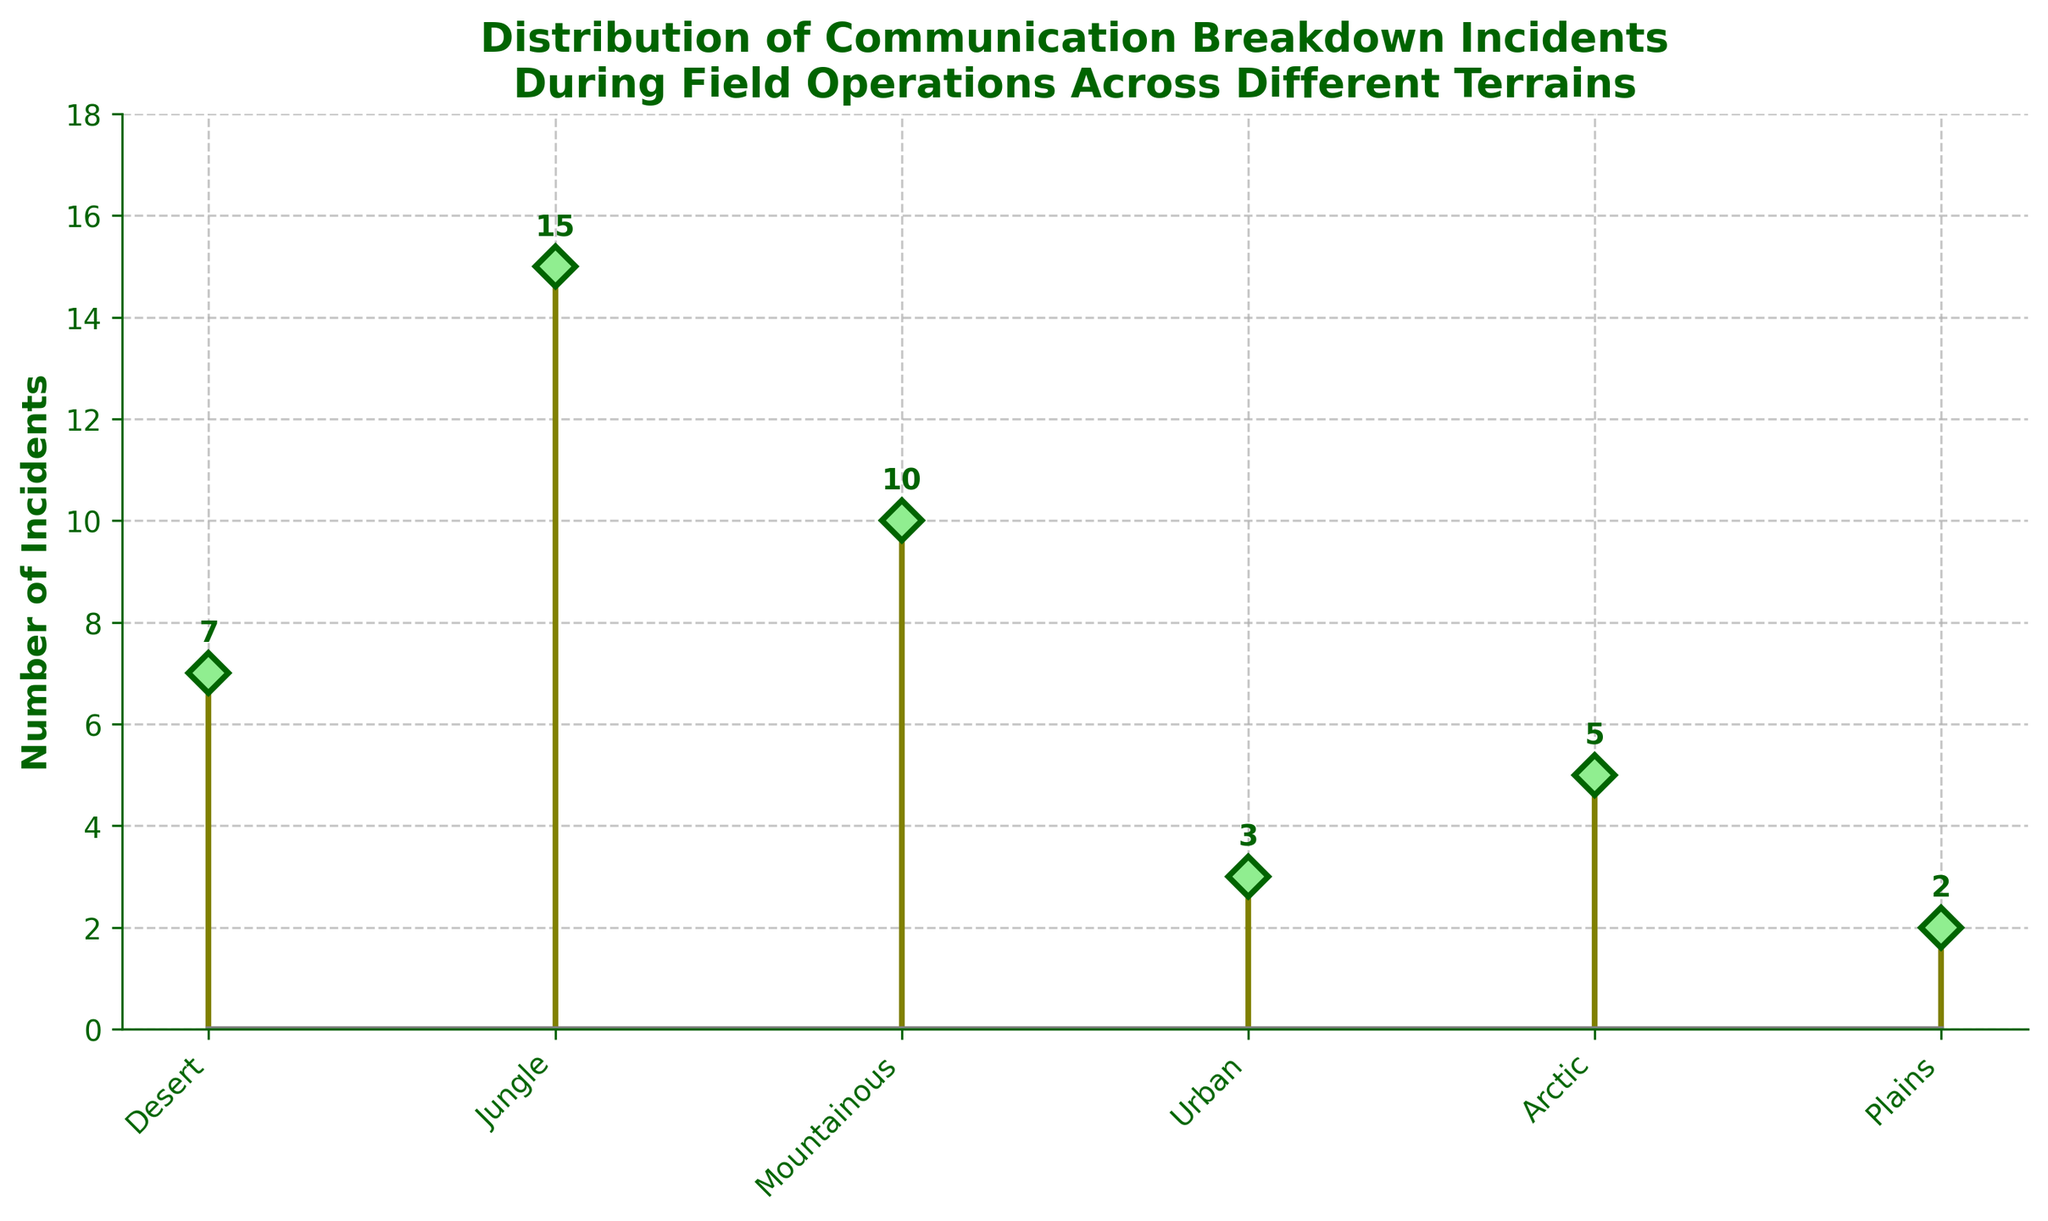What is the title of the plot? The title is displayed at the top of the figure. It reads "Distribution of Communication Breakdown Incidents During Field Operations Across Different Terrains".
Answer: Distribution of Communication Breakdown Incidents During Field Operations Across Different Terrains How many terrains are shown on the plot? Count the number of unique terrain labels on the x-axis. The terrains are Desert, Jungle, Mountainous, Urban, Arctic, and Plains.
Answer: 6 Which terrain has the highest number of communication breakdown incidents? Look at the heights of the stems for each terrain and identify the tallest one. The Jungle terrain has the highest stem.
Answer: Jungle What is the difference in incident counts between Urban and Desert terrains? Look at the height of the stems corresponding to Urban and Desert. Urban has 3 incidents and Desert has 7 incidents. Calculate 7 - 3.
Answer: 4 Which terrains have fewer than 5 incidents? Identify the stems that have a height of less than 5. The Urban and Plains terrains have fewer than 5 incidents (Urban: 3, Plains: 2).
Answer: Urban, Plains What is the total number of incidents across all terrains? Add the heights of all the stems. The incidents are 7 (Desert) + 15 (Jungle) + 10 (Mountainous) + 3 (Urban) + 5 (Arctic) + 2 (Plains). The sum is 42.
Answer: 42 How many more incidents are there in Jungle compared to Arctic? Look at the heights of the stems for Jungle and Arctic. Jungle has 15 incidents, and Arctic has 5. Subtract the number of Arctic incidents from Jungle incidents: 15 - 5.
Answer: 10 What is the mean incident count across all terrains? Calculate the sum of incidents across all terrains and then divide by the number of terrains. Total incidents are 42, and there are 6 terrains: 42 / 6.
Answer: 7 Is the number of incidents in Mountainous terrain closer to those in Urban or Desert terrain? Compare the number of incidents in Mountainous (10) with those in Urban (3) and Desert (7). Calculate the differences: 10 - 3 = 7 (Mountainous-Urban) and 10 - 7 = 3 (Mountainous-Desert). The smaller difference indicates the closer value.
Answer: Desert What is the range of incident counts across the different terrains? Identify the maximum (15 in Jungle) and minimum (2 in Plains) incident counts and calculate the difference: 15 - 2.
Answer: 13 